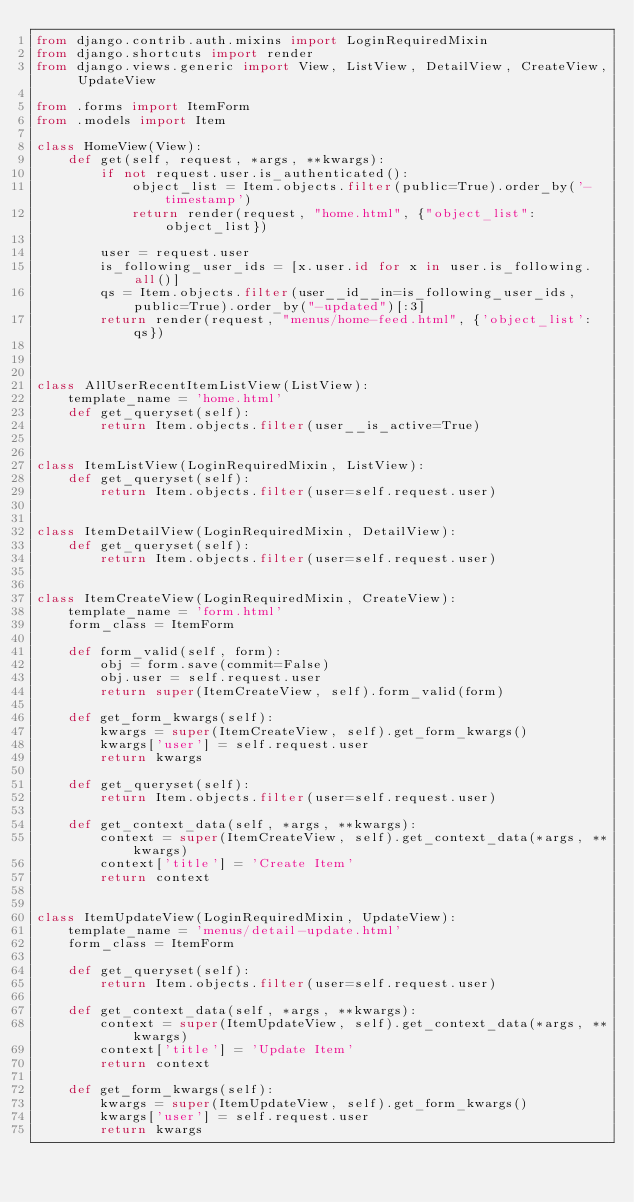<code> <loc_0><loc_0><loc_500><loc_500><_Python_>from django.contrib.auth.mixins import LoginRequiredMixin
from django.shortcuts import render
from django.views.generic import View, ListView, DetailView, CreateView, UpdateView

from .forms import ItemForm
from .models import Item

class HomeView(View):
    def get(self, request, *args, **kwargs):
        if not request.user.is_authenticated():
            object_list = Item.objects.filter(public=True).order_by('-timestamp')
            return render(request, "home.html", {"object_list": object_list})

        user = request.user
        is_following_user_ids = [x.user.id for x in user.is_following.all()]
        qs = Item.objects.filter(user__id__in=is_following_user_ids, public=True).order_by("-updated")[:3]
        return render(request, "menus/home-feed.html", {'object_list': qs})



class AllUserRecentItemListView(ListView):
    template_name = 'home.html'
    def get_queryset(self):
        return Item.objects.filter(user__is_active=True)


class ItemListView(LoginRequiredMixin, ListView):
    def get_queryset(self):
        return Item.objects.filter(user=self.request.user)


class ItemDetailView(LoginRequiredMixin, DetailView):
    def get_queryset(self):
        return Item.objects.filter(user=self.request.user)


class ItemCreateView(LoginRequiredMixin, CreateView):
    template_name = 'form.html'
    form_class = ItemForm

    def form_valid(self, form):
        obj = form.save(commit=False)
        obj.user = self.request.user
        return super(ItemCreateView, self).form_valid(form)

    def get_form_kwargs(self):
        kwargs = super(ItemCreateView, self).get_form_kwargs()
        kwargs['user'] = self.request.user
        return kwargs

    def get_queryset(self):
        return Item.objects.filter(user=self.request.user)

    def get_context_data(self, *args, **kwargs):
        context = super(ItemCreateView, self).get_context_data(*args, **kwargs)
        context['title'] = 'Create Item'
        return context


class ItemUpdateView(LoginRequiredMixin, UpdateView):
    template_name = 'menus/detail-update.html'
    form_class = ItemForm

    def get_queryset(self):
        return Item.objects.filter(user=self.request.user)

    def get_context_data(self, *args, **kwargs):
        context = super(ItemUpdateView, self).get_context_data(*args, **kwargs)
        context['title'] = 'Update Item'
        return context

    def get_form_kwargs(self):
        kwargs = super(ItemUpdateView, self).get_form_kwargs()
        kwargs['user'] = self.request.user
        return kwargs

</code> 